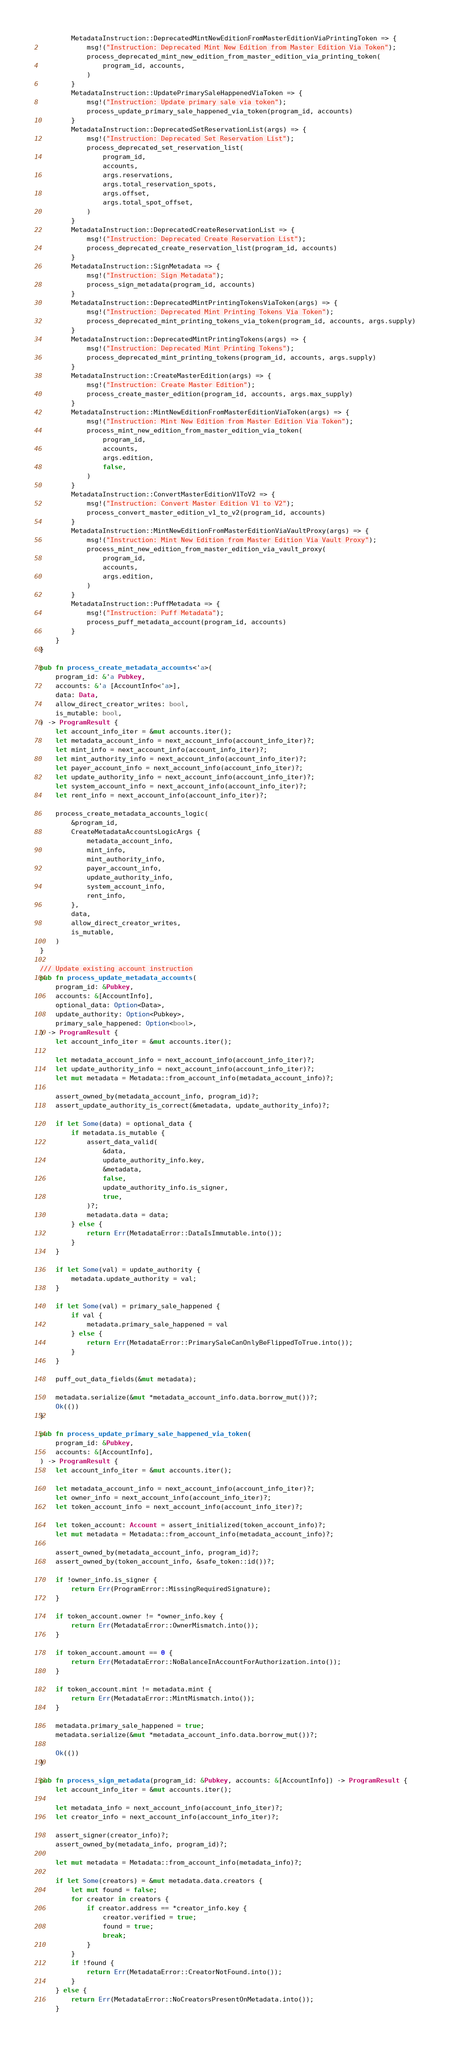<code> <loc_0><loc_0><loc_500><loc_500><_Rust_>        MetadataInstruction::DeprecatedMintNewEditionFromMasterEditionViaPrintingToken => {
            msg!("Instruction: Deprecated Mint New Edition from Master Edition Via Token");
            process_deprecated_mint_new_edition_from_master_edition_via_printing_token(
                program_id, accounts,
            )
        }
        MetadataInstruction::UpdatePrimarySaleHappenedViaToken => {
            msg!("Instruction: Update primary sale via token");
            process_update_primary_sale_happened_via_token(program_id, accounts)
        }
        MetadataInstruction::DeprecatedSetReservationList(args) => {
            msg!("Instruction: Deprecated Set Reservation List");
            process_deprecated_set_reservation_list(
                program_id,
                accounts,
                args.reservations,
                args.total_reservation_spots,
                args.offset,
                args.total_spot_offset,
            )
        }
        MetadataInstruction::DeprecatedCreateReservationList => {
            msg!("Instruction: Deprecated Create Reservation List");
            process_deprecated_create_reservation_list(program_id, accounts)
        }
        MetadataInstruction::SignMetadata => {
            msg!("Instruction: Sign Metadata");
            process_sign_metadata(program_id, accounts)
        }
        MetadataInstruction::DeprecatedMintPrintingTokensViaToken(args) => {
            msg!("Instruction: Deprecated Mint Printing Tokens Via Token");
            process_deprecated_mint_printing_tokens_via_token(program_id, accounts, args.supply)
        }
        MetadataInstruction::DeprecatedMintPrintingTokens(args) => {
            msg!("Instruction: Deprecated Mint Printing Tokens");
            process_deprecated_mint_printing_tokens(program_id, accounts, args.supply)
        }
        MetadataInstruction::CreateMasterEdition(args) => {
            msg!("Instruction: Create Master Edition");
            process_create_master_edition(program_id, accounts, args.max_supply)
        }
        MetadataInstruction::MintNewEditionFromMasterEditionViaToken(args) => {
            msg!("Instruction: Mint New Edition from Master Edition Via Token");
            process_mint_new_edition_from_master_edition_via_token(
                program_id,
                accounts,
                args.edition,
                false,
            )
        }
        MetadataInstruction::ConvertMasterEditionV1ToV2 => {
            msg!("Instruction: Convert Master Edition V1 to V2");
            process_convert_master_edition_v1_to_v2(program_id, accounts)
        }
        MetadataInstruction::MintNewEditionFromMasterEditionViaVaultProxy(args) => {
            msg!("Instruction: Mint New Edition from Master Edition Via Vault Proxy");
            process_mint_new_edition_from_master_edition_via_vault_proxy(
                program_id,
                accounts,
                args.edition,
            )
        }
        MetadataInstruction::PuffMetadata => {
            msg!("Instruction: Puff Metadata");
            process_puff_metadata_account(program_id, accounts)
        }
    }
}

pub fn process_create_metadata_accounts<'a>(
    program_id: &'a Pubkey,
    accounts: &'a [AccountInfo<'a>],
    data: Data,
    allow_direct_creator_writes: bool,
    is_mutable: bool,
) -> ProgramResult {
    let account_info_iter = &mut accounts.iter();
    let metadata_account_info = next_account_info(account_info_iter)?;
    let mint_info = next_account_info(account_info_iter)?;
    let mint_authority_info = next_account_info(account_info_iter)?;
    let payer_account_info = next_account_info(account_info_iter)?;
    let update_authority_info = next_account_info(account_info_iter)?;
    let system_account_info = next_account_info(account_info_iter)?;
    let rent_info = next_account_info(account_info_iter)?;

    process_create_metadata_accounts_logic(
        &program_id,
        CreateMetadataAccountsLogicArgs {
            metadata_account_info,
            mint_info,
            mint_authority_info,
            payer_account_info,
            update_authority_info,
            system_account_info,
            rent_info,
        },
        data,
        allow_direct_creator_writes,
        is_mutable,
    )
}

/// Update existing account instruction
pub fn process_update_metadata_accounts(
    program_id: &Pubkey,
    accounts: &[AccountInfo],
    optional_data: Option<Data>,
    update_authority: Option<Pubkey>,
    primary_sale_happened: Option<bool>,
) -> ProgramResult {
    let account_info_iter = &mut accounts.iter();

    let metadata_account_info = next_account_info(account_info_iter)?;
    let update_authority_info = next_account_info(account_info_iter)?;
    let mut metadata = Metadata::from_account_info(metadata_account_info)?;

    assert_owned_by(metadata_account_info, program_id)?;
    assert_update_authority_is_correct(&metadata, update_authority_info)?;

    if let Some(data) = optional_data {
        if metadata.is_mutable {
            assert_data_valid(
                &data,
                update_authority_info.key,
                &metadata,
                false,
                update_authority_info.is_signer,
                true,
            )?;
            metadata.data = data;
        } else {
            return Err(MetadataError::DataIsImmutable.into());
        }
    }

    if let Some(val) = update_authority {
        metadata.update_authority = val;
    }

    if let Some(val) = primary_sale_happened {
        if val {
            metadata.primary_sale_happened = val
        } else {
            return Err(MetadataError::PrimarySaleCanOnlyBeFlippedToTrue.into());
        }
    }

    puff_out_data_fields(&mut metadata);

    metadata.serialize(&mut *metadata_account_info.data.borrow_mut())?;
    Ok(())
}

pub fn process_update_primary_sale_happened_via_token(
    program_id: &Pubkey,
    accounts: &[AccountInfo],
) -> ProgramResult {
    let account_info_iter = &mut accounts.iter();

    let metadata_account_info = next_account_info(account_info_iter)?;
    let owner_info = next_account_info(account_info_iter)?;
    let token_account_info = next_account_info(account_info_iter)?;

    let token_account: Account = assert_initialized(token_account_info)?;
    let mut metadata = Metadata::from_account_info(metadata_account_info)?;

    assert_owned_by(metadata_account_info, program_id)?;
    assert_owned_by(token_account_info, &safe_token::id())?;

    if !owner_info.is_signer {
        return Err(ProgramError::MissingRequiredSignature);
    }

    if token_account.owner != *owner_info.key {
        return Err(MetadataError::OwnerMismatch.into());
    }

    if token_account.amount == 0 {
        return Err(MetadataError::NoBalanceInAccountForAuthorization.into());
    }

    if token_account.mint != metadata.mint {
        return Err(MetadataError::MintMismatch.into());
    }

    metadata.primary_sale_happened = true;
    metadata.serialize(&mut *metadata_account_info.data.borrow_mut())?;

    Ok(())
}

pub fn process_sign_metadata(program_id: &Pubkey, accounts: &[AccountInfo]) -> ProgramResult {
    let account_info_iter = &mut accounts.iter();

    let metadata_info = next_account_info(account_info_iter)?;
    let creator_info = next_account_info(account_info_iter)?;

    assert_signer(creator_info)?;
    assert_owned_by(metadata_info, program_id)?;

    let mut metadata = Metadata::from_account_info(metadata_info)?;

    if let Some(creators) = &mut metadata.data.creators {
        let mut found = false;
        for creator in creators {
            if creator.address == *creator_info.key {
                creator.verified = true;
                found = true;
                break;
            }
        }
        if !found {
            return Err(MetadataError::CreatorNotFound.into());
        }
    } else {
        return Err(MetadataError::NoCreatorsPresentOnMetadata.into());
    }</code> 